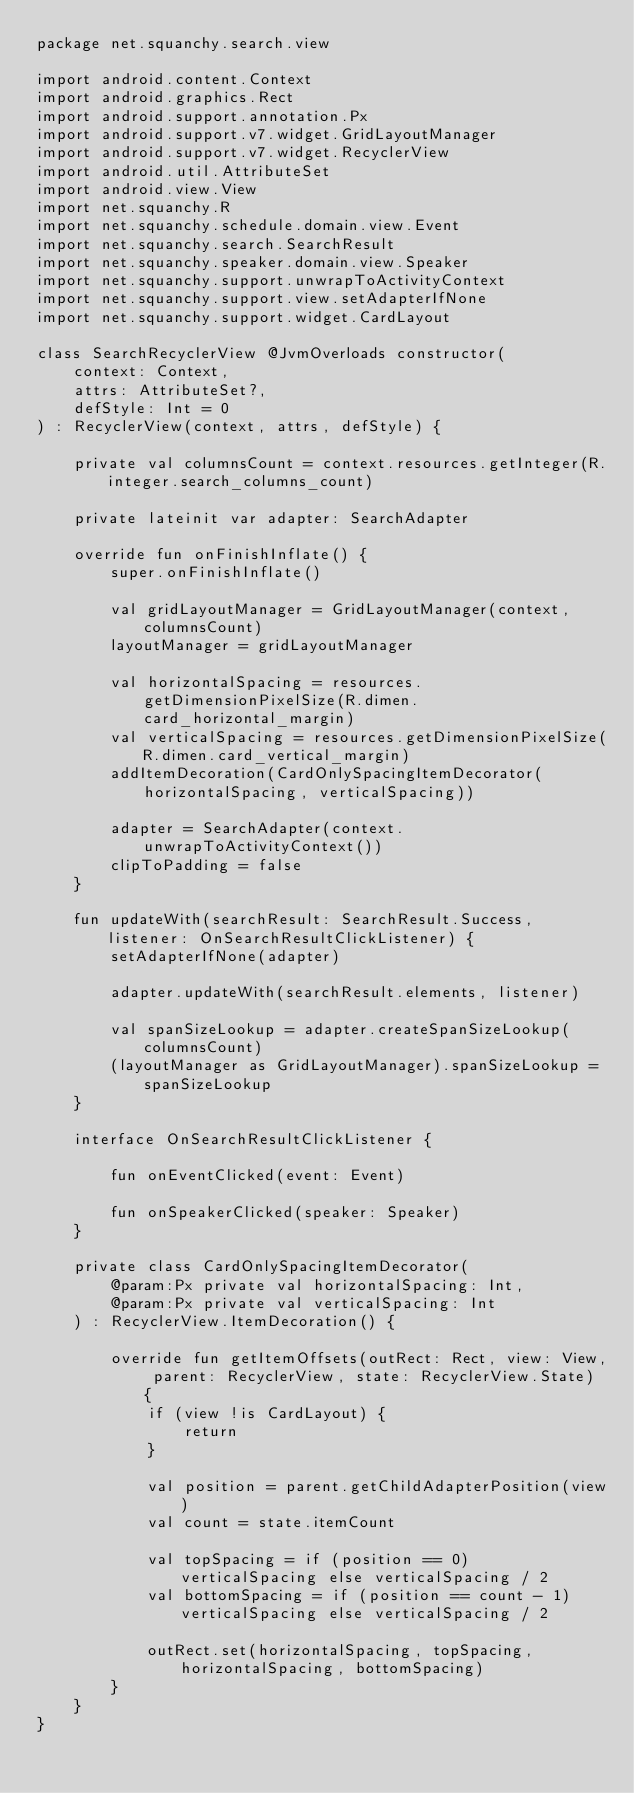<code> <loc_0><loc_0><loc_500><loc_500><_Kotlin_>package net.squanchy.search.view

import android.content.Context
import android.graphics.Rect
import android.support.annotation.Px
import android.support.v7.widget.GridLayoutManager
import android.support.v7.widget.RecyclerView
import android.util.AttributeSet
import android.view.View
import net.squanchy.R
import net.squanchy.schedule.domain.view.Event
import net.squanchy.search.SearchResult
import net.squanchy.speaker.domain.view.Speaker
import net.squanchy.support.unwrapToActivityContext
import net.squanchy.support.view.setAdapterIfNone
import net.squanchy.support.widget.CardLayout

class SearchRecyclerView @JvmOverloads constructor(
    context: Context,
    attrs: AttributeSet?,
    defStyle: Int = 0
) : RecyclerView(context, attrs, defStyle) {

    private val columnsCount = context.resources.getInteger(R.integer.search_columns_count)

    private lateinit var adapter: SearchAdapter

    override fun onFinishInflate() {
        super.onFinishInflate()

        val gridLayoutManager = GridLayoutManager(context, columnsCount)
        layoutManager = gridLayoutManager

        val horizontalSpacing = resources.getDimensionPixelSize(R.dimen.card_horizontal_margin)
        val verticalSpacing = resources.getDimensionPixelSize(R.dimen.card_vertical_margin)
        addItemDecoration(CardOnlySpacingItemDecorator(horizontalSpacing, verticalSpacing))

        adapter = SearchAdapter(context.unwrapToActivityContext())
        clipToPadding = false
    }

    fun updateWith(searchResult: SearchResult.Success, listener: OnSearchResultClickListener) {
        setAdapterIfNone(adapter)

        adapter.updateWith(searchResult.elements, listener)

        val spanSizeLookup = adapter.createSpanSizeLookup(columnsCount)
        (layoutManager as GridLayoutManager).spanSizeLookup = spanSizeLookup
    }

    interface OnSearchResultClickListener {

        fun onEventClicked(event: Event)

        fun onSpeakerClicked(speaker: Speaker)
    }

    private class CardOnlySpacingItemDecorator(
        @param:Px private val horizontalSpacing: Int,
        @param:Px private val verticalSpacing: Int
    ) : RecyclerView.ItemDecoration() {

        override fun getItemOffsets(outRect: Rect, view: View, parent: RecyclerView, state: RecyclerView.State) {
            if (view !is CardLayout) {
                return
            }

            val position = parent.getChildAdapterPosition(view)
            val count = state.itemCount

            val topSpacing = if (position == 0) verticalSpacing else verticalSpacing / 2
            val bottomSpacing = if (position == count - 1) verticalSpacing else verticalSpacing / 2

            outRect.set(horizontalSpacing, topSpacing, horizontalSpacing, bottomSpacing)
        }
    }
}
</code> 